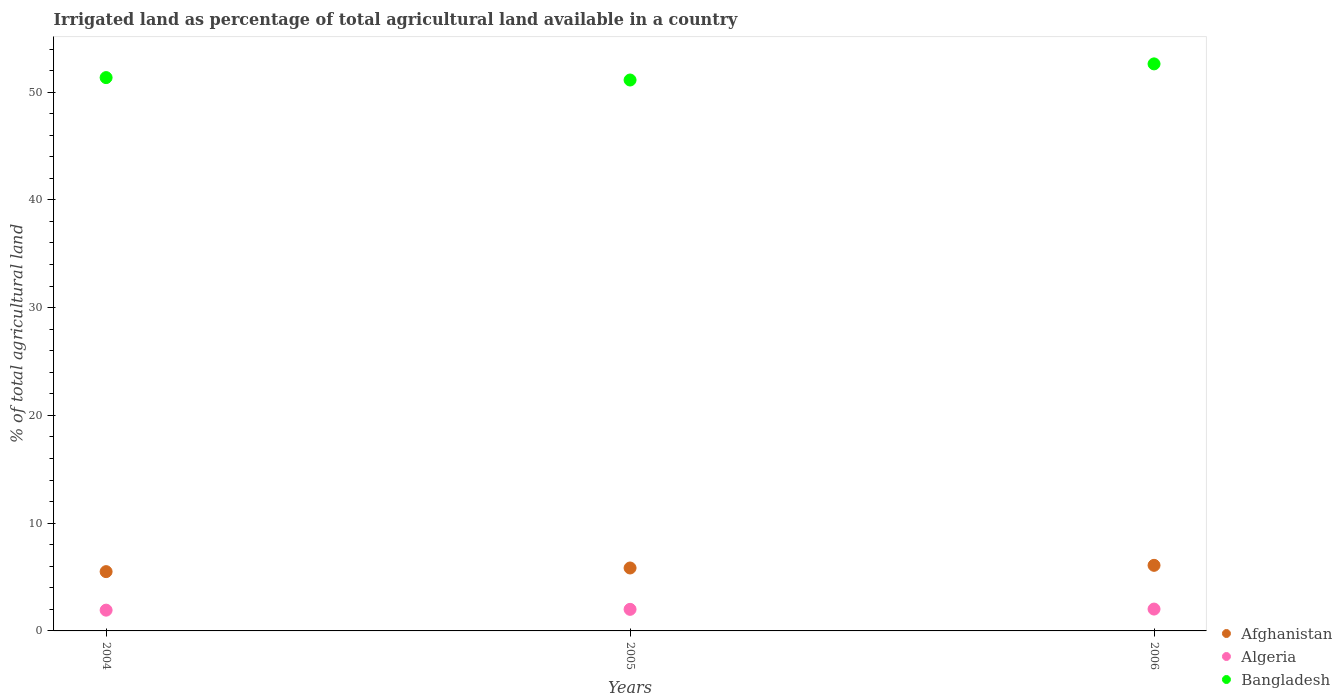How many different coloured dotlines are there?
Offer a terse response. 3. Is the number of dotlines equal to the number of legend labels?
Provide a succinct answer. Yes. What is the percentage of irrigated land in Afghanistan in 2005?
Offer a terse response. 5.84. Across all years, what is the maximum percentage of irrigated land in Bangladesh?
Keep it short and to the point. 52.62. Across all years, what is the minimum percentage of irrigated land in Algeria?
Your answer should be very brief. 1.93. What is the total percentage of irrigated land in Algeria in the graph?
Give a very brief answer. 5.96. What is the difference between the percentage of irrigated land in Algeria in 2004 and that in 2005?
Your answer should be compact. -0.07. What is the difference between the percentage of irrigated land in Algeria in 2004 and the percentage of irrigated land in Bangladesh in 2005?
Offer a very short reply. -49.19. What is the average percentage of irrigated land in Bangladesh per year?
Keep it short and to the point. 51.7. In the year 2006, what is the difference between the percentage of irrigated land in Afghanistan and percentage of irrigated land in Algeria?
Provide a succinct answer. 4.06. What is the ratio of the percentage of irrigated land in Bangladesh in 2004 to that in 2006?
Provide a short and direct response. 0.98. Is the percentage of irrigated land in Algeria in 2004 less than that in 2006?
Your answer should be compact. Yes. What is the difference between the highest and the second highest percentage of irrigated land in Afghanistan?
Your answer should be very brief. 0.25. What is the difference between the highest and the lowest percentage of irrigated land in Algeria?
Your answer should be very brief. 0.1. In how many years, is the percentage of irrigated land in Bangladesh greater than the average percentage of irrigated land in Bangladesh taken over all years?
Ensure brevity in your answer.  1. Is the sum of the percentage of irrigated land in Afghanistan in 2005 and 2006 greater than the maximum percentage of irrigated land in Bangladesh across all years?
Your response must be concise. No. Does the percentage of irrigated land in Bangladesh monotonically increase over the years?
Provide a short and direct response. No. Is the percentage of irrigated land in Afghanistan strictly less than the percentage of irrigated land in Bangladesh over the years?
Your response must be concise. Yes. How many dotlines are there?
Keep it short and to the point. 3. Are the values on the major ticks of Y-axis written in scientific E-notation?
Offer a very short reply. No. Does the graph contain any zero values?
Provide a short and direct response. No. Where does the legend appear in the graph?
Your answer should be very brief. Bottom right. How are the legend labels stacked?
Provide a succinct answer. Vertical. What is the title of the graph?
Provide a short and direct response. Irrigated land as percentage of total agricultural land available in a country. Does "Small states" appear as one of the legend labels in the graph?
Keep it short and to the point. No. What is the label or title of the X-axis?
Provide a succinct answer. Years. What is the label or title of the Y-axis?
Provide a short and direct response. % of total agricultural land. What is the % of total agricultural land in Afghanistan in 2004?
Ensure brevity in your answer.  5.5. What is the % of total agricultural land in Algeria in 2004?
Keep it short and to the point. 1.93. What is the % of total agricultural land of Bangladesh in 2004?
Give a very brief answer. 51.35. What is the % of total agricultural land in Afghanistan in 2005?
Provide a short and direct response. 5.84. What is the % of total agricultural land of Algeria in 2005?
Your answer should be very brief. 2. What is the % of total agricultural land of Bangladesh in 2005?
Your answer should be very brief. 51.12. What is the % of total agricultural land in Afghanistan in 2006?
Make the answer very short. 6.09. What is the % of total agricultural land in Algeria in 2006?
Ensure brevity in your answer.  2.03. What is the % of total agricultural land in Bangladesh in 2006?
Your answer should be very brief. 52.62. Across all years, what is the maximum % of total agricultural land of Afghanistan?
Make the answer very short. 6.09. Across all years, what is the maximum % of total agricultural land in Algeria?
Keep it short and to the point. 2.03. Across all years, what is the maximum % of total agricultural land in Bangladesh?
Ensure brevity in your answer.  52.62. Across all years, what is the minimum % of total agricultural land in Afghanistan?
Your answer should be compact. 5.5. Across all years, what is the minimum % of total agricultural land of Algeria?
Your answer should be compact. 1.93. Across all years, what is the minimum % of total agricultural land of Bangladesh?
Your answer should be very brief. 51.12. What is the total % of total agricultural land in Afghanistan in the graph?
Provide a succinct answer. 17.43. What is the total % of total agricultural land of Algeria in the graph?
Give a very brief answer. 5.96. What is the total % of total agricultural land of Bangladesh in the graph?
Provide a short and direct response. 155.09. What is the difference between the % of total agricultural land in Afghanistan in 2004 and that in 2005?
Your response must be concise. -0.34. What is the difference between the % of total agricultural land of Algeria in 2004 and that in 2005?
Keep it short and to the point. -0.07. What is the difference between the % of total agricultural land of Bangladesh in 2004 and that in 2005?
Make the answer very short. 0.22. What is the difference between the % of total agricultural land in Afghanistan in 2004 and that in 2006?
Provide a succinct answer. -0.58. What is the difference between the % of total agricultural land in Algeria in 2004 and that in 2006?
Offer a terse response. -0.1. What is the difference between the % of total agricultural land in Bangladesh in 2004 and that in 2006?
Offer a very short reply. -1.27. What is the difference between the % of total agricultural land of Afghanistan in 2005 and that in 2006?
Provide a succinct answer. -0.25. What is the difference between the % of total agricultural land of Algeria in 2005 and that in 2006?
Your answer should be very brief. -0.03. What is the difference between the % of total agricultural land in Bangladesh in 2005 and that in 2006?
Provide a succinct answer. -1.5. What is the difference between the % of total agricultural land of Afghanistan in 2004 and the % of total agricultural land of Algeria in 2005?
Your response must be concise. 3.5. What is the difference between the % of total agricultural land of Afghanistan in 2004 and the % of total agricultural land of Bangladesh in 2005?
Provide a short and direct response. -45.62. What is the difference between the % of total agricultural land in Algeria in 2004 and the % of total agricultural land in Bangladesh in 2005?
Provide a succinct answer. -49.2. What is the difference between the % of total agricultural land of Afghanistan in 2004 and the % of total agricultural land of Algeria in 2006?
Ensure brevity in your answer.  3.47. What is the difference between the % of total agricultural land in Afghanistan in 2004 and the % of total agricultural land in Bangladesh in 2006?
Ensure brevity in your answer.  -47.12. What is the difference between the % of total agricultural land of Algeria in 2004 and the % of total agricultural land of Bangladesh in 2006?
Provide a succinct answer. -50.69. What is the difference between the % of total agricultural land of Afghanistan in 2005 and the % of total agricultural land of Algeria in 2006?
Provide a short and direct response. 3.81. What is the difference between the % of total agricultural land of Afghanistan in 2005 and the % of total agricultural land of Bangladesh in 2006?
Your answer should be compact. -46.78. What is the difference between the % of total agricultural land in Algeria in 2005 and the % of total agricultural land in Bangladesh in 2006?
Keep it short and to the point. -50.62. What is the average % of total agricultural land of Afghanistan per year?
Your response must be concise. 5.81. What is the average % of total agricultural land in Algeria per year?
Offer a very short reply. 1.99. What is the average % of total agricultural land in Bangladesh per year?
Your response must be concise. 51.7. In the year 2004, what is the difference between the % of total agricultural land of Afghanistan and % of total agricultural land of Algeria?
Provide a short and direct response. 3.58. In the year 2004, what is the difference between the % of total agricultural land in Afghanistan and % of total agricultural land in Bangladesh?
Make the answer very short. -45.84. In the year 2004, what is the difference between the % of total agricultural land in Algeria and % of total agricultural land in Bangladesh?
Provide a succinct answer. -49.42. In the year 2005, what is the difference between the % of total agricultural land of Afghanistan and % of total agricultural land of Algeria?
Provide a short and direct response. 3.84. In the year 2005, what is the difference between the % of total agricultural land in Afghanistan and % of total agricultural land in Bangladesh?
Your answer should be very brief. -45.28. In the year 2005, what is the difference between the % of total agricultural land of Algeria and % of total agricultural land of Bangladesh?
Your answer should be compact. -49.12. In the year 2006, what is the difference between the % of total agricultural land of Afghanistan and % of total agricultural land of Algeria?
Offer a terse response. 4.06. In the year 2006, what is the difference between the % of total agricultural land of Afghanistan and % of total agricultural land of Bangladesh?
Provide a succinct answer. -46.53. In the year 2006, what is the difference between the % of total agricultural land in Algeria and % of total agricultural land in Bangladesh?
Provide a succinct answer. -50.59. What is the ratio of the % of total agricultural land of Afghanistan in 2004 to that in 2005?
Offer a very short reply. 0.94. What is the ratio of the % of total agricultural land in Algeria in 2004 to that in 2005?
Your response must be concise. 0.96. What is the ratio of the % of total agricultural land in Bangladesh in 2004 to that in 2005?
Offer a very short reply. 1. What is the ratio of the % of total agricultural land of Afghanistan in 2004 to that in 2006?
Ensure brevity in your answer.  0.9. What is the ratio of the % of total agricultural land of Algeria in 2004 to that in 2006?
Give a very brief answer. 0.95. What is the ratio of the % of total agricultural land in Bangladesh in 2004 to that in 2006?
Give a very brief answer. 0.98. What is the ratio of the % of total agricultural land in Afghanistan in 2005 to that in 2006?
Offer a terse response. 0.96. What is the ratio of the % of total agricultural land of Algeria in 2005 to that in 2006?
Offer a very short reply. 0.99. What is the ratio of the % of total agricultural land in Bangladesh in 2005 to that in 2006?
Your response must be concise. 0.97. What is the difference between the highest and the second highest % of total agricultural land of Afghanistan?
Make the answer very short. 0.25. What is the difference between the highest and the second highest % of total agricultural land in Algeria?
Provide a short and direct response. 0.03. What is the difference between the highest and the second highest % of total agricultural land of Bangladesh?
Offer a very short reply. 1.27. What is the difference between the highest and the lowest % of total agricultural land of Afghanistan?
Your answer should be compact. 0.58. What is the difference between the highest and the lowest % of total agricultural land of Algeria?
Provide a short and direct response. 0.1. What is the difference between the highest and the lowest % of total agricultural land of Bangladesh?
Give a very brief answer. 1.5. 